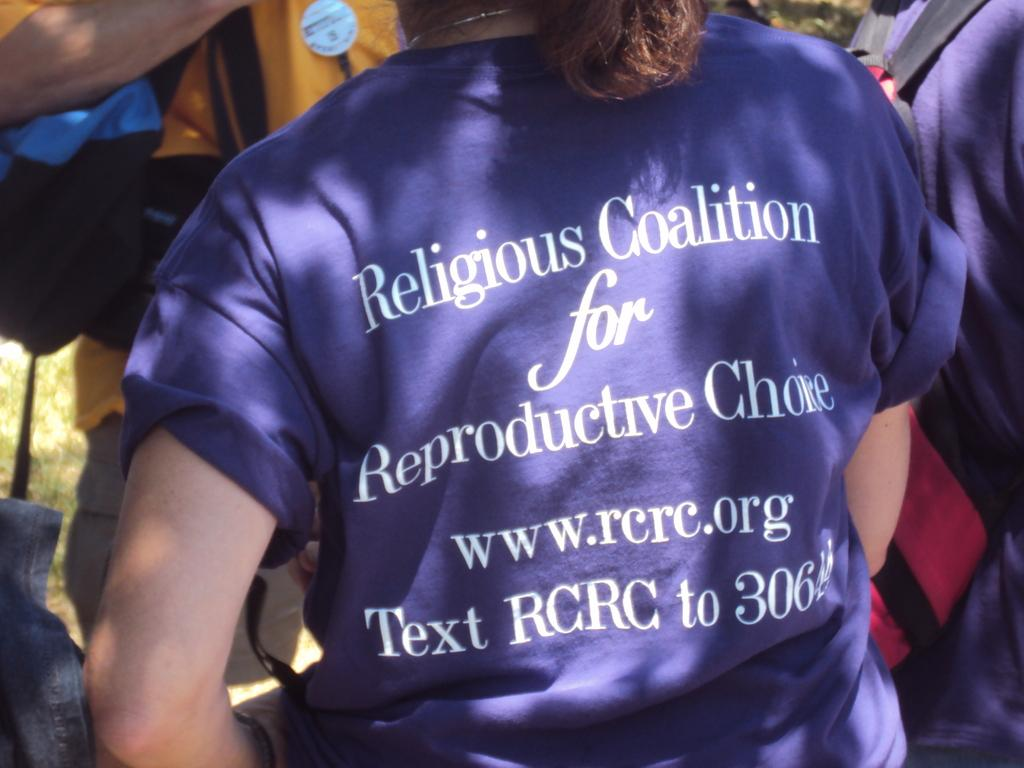<image>
Present a compact description of the photo's key features. A t-shirt for the Religious Coalition for Reproductive choice. 